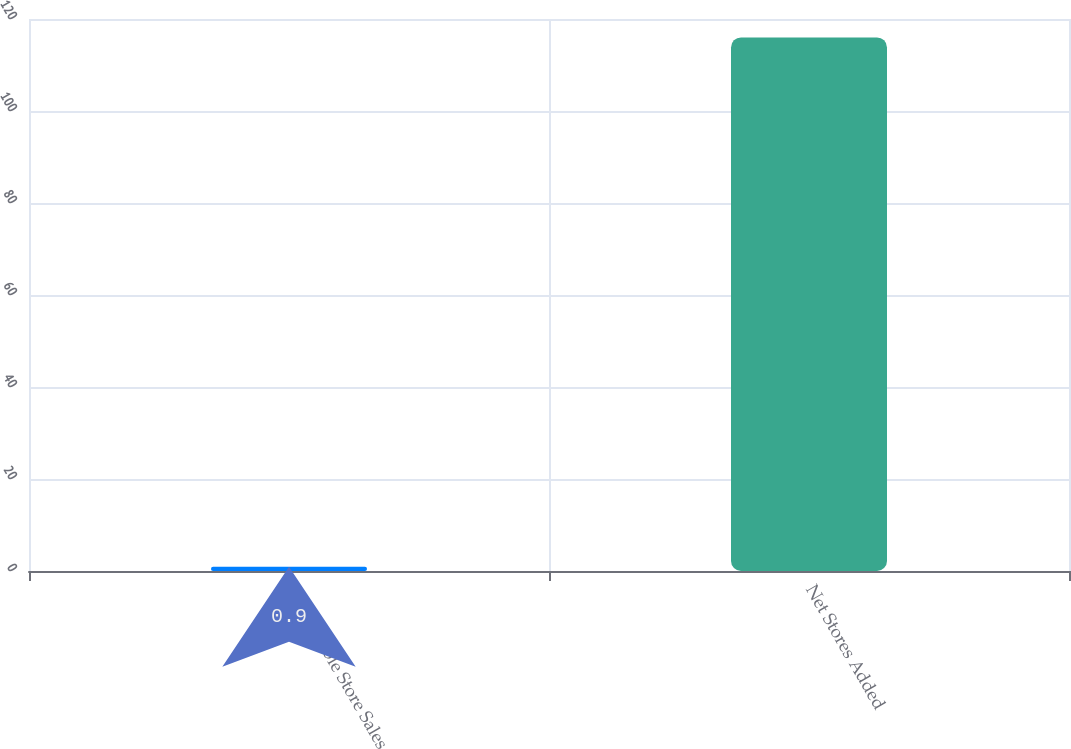Convert chart. <chart><loc_0><loc_0><loc_500><loc_500><bar_chart><fcel>Comparable Store Sales<fcel>Net Stores Added<nl><fcel>0.9<fcel>116<nl></chart> 